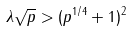<formula> <loc_0><loc_0><loc_500><loc_500>\lambda \sqrt { p } > ( p ^ { 1 / 4 } + 1 ) ^ { 2 }</formula> 